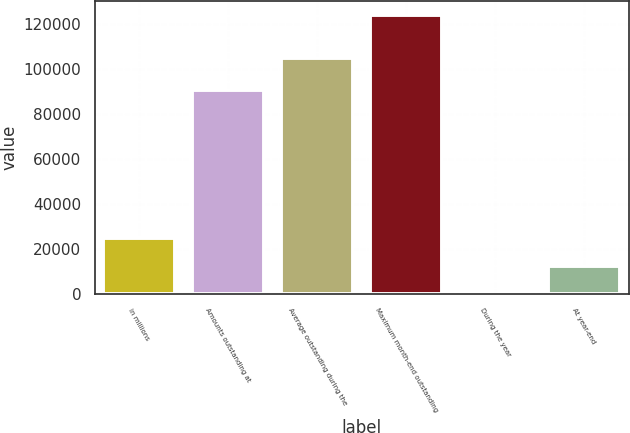<chart> <loc_0><loc_0><loc_500><loc_500><bar_chart><fcel>in millions<fcel>Amounts outstanding at<fcel>Average outstanding during the<fcel>Maximum month-end outstanding<fcel>During the year<fcel>At year-end<nl><fcel>24762.6<fcel>90531<fcel>104876<fcel>123805<fcel>1.96<fcel>12382.3<nl></chart> 